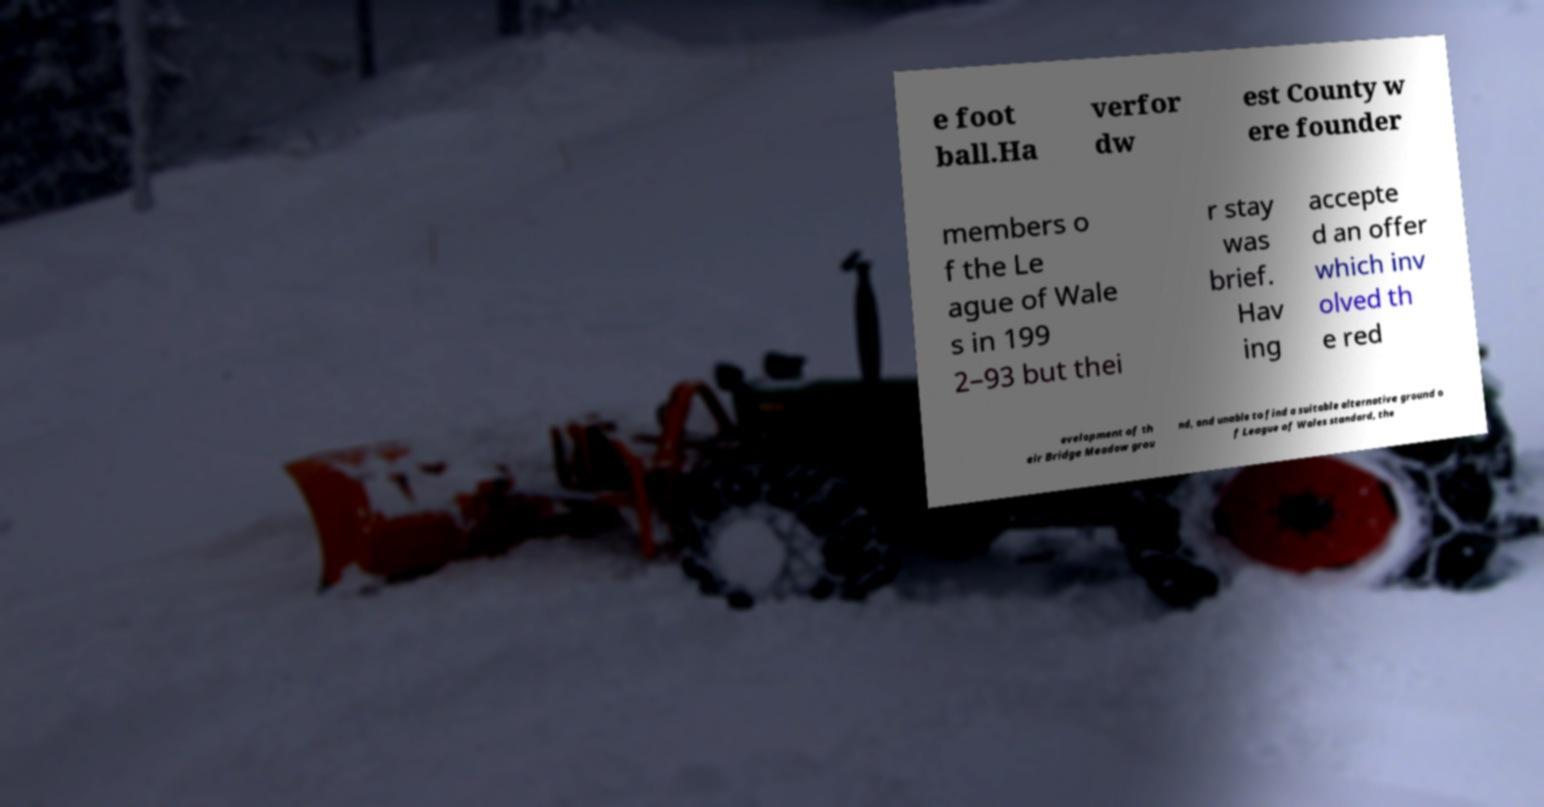Please identify and transcribe the text found in this image. e foot ball.Ha verfor dw est County w ere founder members o f the Le ague of Wale s in 199 2–93 but thei r stay was brief. Hav ing accepte d an offer which inv olved th e red evelopment of th eir Bridge Meadow grou nd, and unable to find a suitable alternative ground o f League of Wales standard, the 